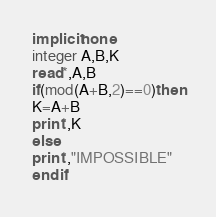<code> <loc_0><loc_0><loc_500><loc_500><_FORTRAN_>implicit none
integer A,B,K
read*,A,B
if(mod(A+B,2)==0)then
K=A+B
print*,K
else 
print*,"IMPOSSIBLE"
end	if

</code> 